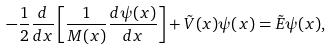Convert formula to latex. <formula><loc_0><loc_0><loc_500><loc_500>- \frac { 1 } { 2 } \frac { d } { d x } \left [ \frac { 1 } { M ( x ) } \frac { d \psi ( x ) } { d x } \right ] + \tilde { V } ( x ) \psi ( x ) = \tilde { E } \psi ( x ) ,</formula> 